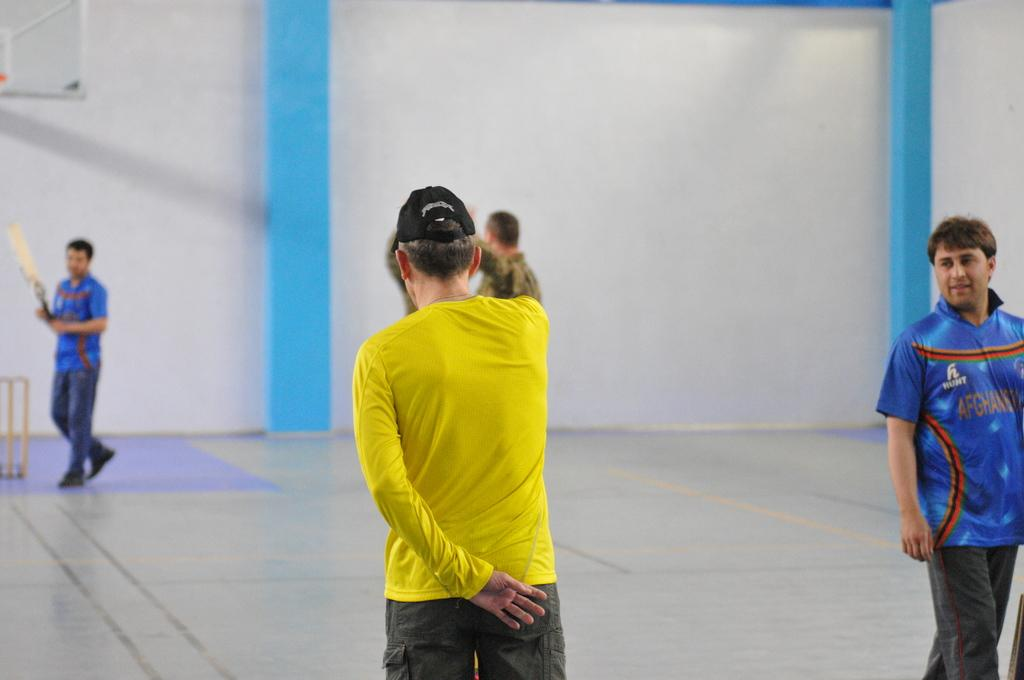<image>
Provide a brief description of the given image. Men are playing a game, the players in blue are from Afghanistan. 